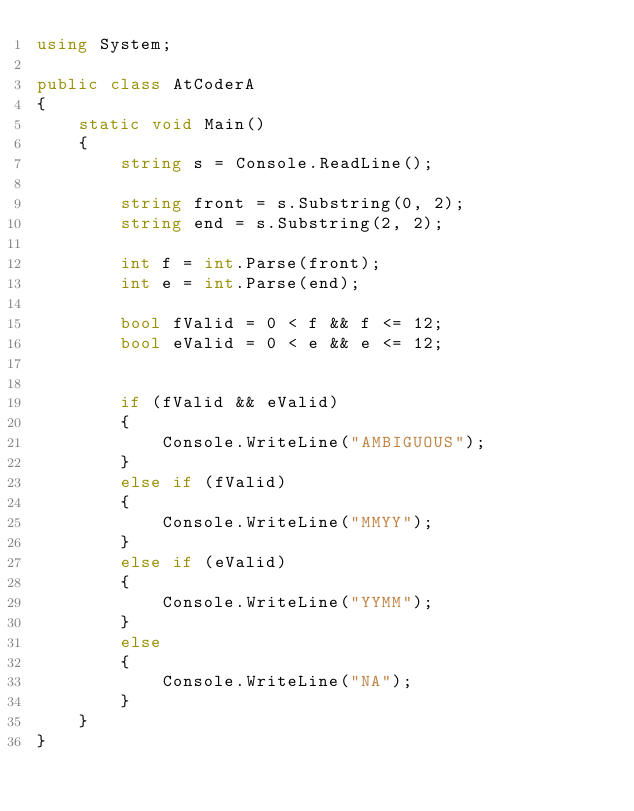Convert code to text. <code><loc_0><loc_0><loc_500><loc_500><_C#_>using System;

public class AtCoderA
{
    static void Main()
    {
        string s = Console.ReadLine();

        string front = s.Substring(0, 2);
        string end = s.Substring(2, 2);

        int f = int.Parse(front);
        int e = int.Parse(end);

        bool fValid = 0 < f && f <= 12;
        bool eValid = 0 < e && e <= 12;


        if (fValid && eValid)
        {
            Console.WriteLine("AMBIGUOUS");
        }
        else if (fValid)
        {
            Console.WriteLine("MMYY");
        }
        else if (eValid)
        {
            Console.WriteLine("YYMM");
        }
        else
        {
            Console.WriteLine("NA");
        }
    }
}</code> 